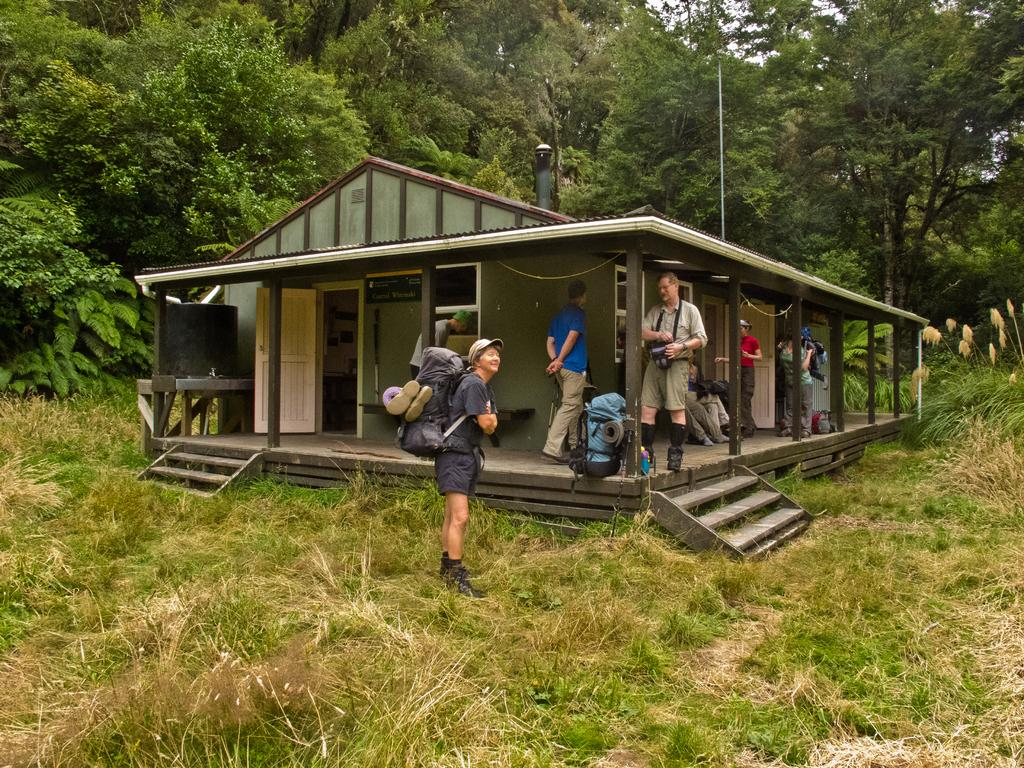What type of structure is visible in the image? There is a house in the image. Who or what can be seen in the image besides the house? There are people and trees visible in the image. What is the ground surface like in the image? There is grass in the image. What else can be seen in the image besides the house, people, trees, and grass? There are objects in the image. What might suggest that the people in the image are preparing for a trip? The presence of luggages near the people suggests they might be preparing for a trip. Can you tell me how many goldfish are swimming in the grass in the image? There are no goldfish present in the image; it features a house, people, trees, and grass. What type of crate is being used to hold the people's ears in the image? There is no crate or mention of ears in the image. 